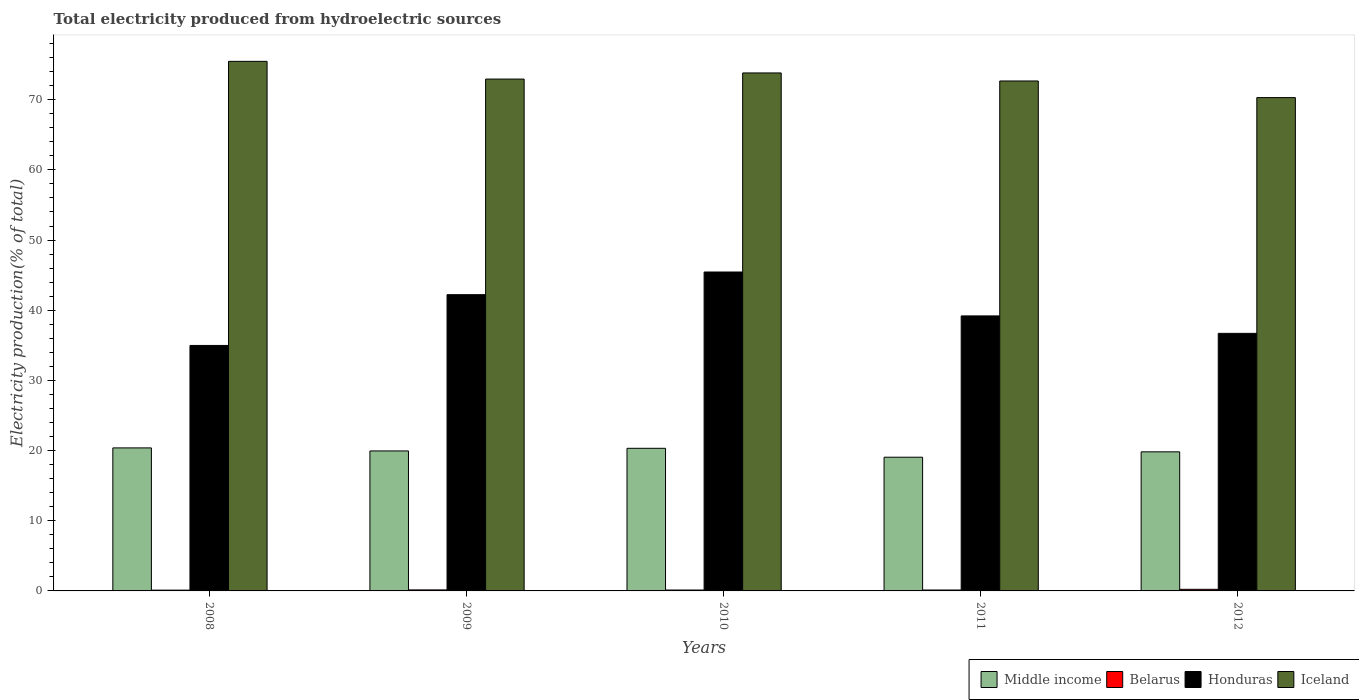How many different coloured bars are there?
Offer a terse response. 4. Are the number of bars per tick equal to the number of legend labels?
Your answer should be very brief. Yes. Are the number of bars on each tick of the X-axis equal?
Offer a terse response. Yes. How many bars are there on the 1st tick from the left?
Your answer should be very brief. 4. What is the label of the 2nd group of bars from the left?
Ensure brevity in your answer.  2009. In how many cases, is the number of bars for a given year not equal to the number of legend labels?
Keep it short and to the point. 0. What is the total electricity produced in Honduras in 2010?
Offer a very short reply. 45.45. Across all years, what is the maximum total electricity produced in Middle income?
Offer a very short reply. 20.38. Across all years, what is the minimum total electricity produced in Honduras?
Provide a succinct answer. 34.98. In which year was the total electricity produced in Middle income maximum?
Ensure brevity in your answer.  2008. What is the total total electricity produced in Iceland in the graph?
Your answer should be very brief. 365.19. What is the difference between the total electricity produced in Iceland in 2009 and that in 2011?
Your response must be concise. 0.27. What is the difference between the total electricity produced in Iceland in 2008 and the total electricity produced in Middle income in 2011?
Make the answer very short. 56.41. What is the average total electricity produced in Belarus per year?
Offer a very short reply. 0.15. In the year 2008, what is the difference between the total electricity produced in Honduras and total electricity produced in Middle income?
Provide a succinct answer. 14.6. What is the ratio of the total electricity produced in Iceland in 2008 to that in 2011?
Ensure brevity in your answer.  1.04. What is the difference between the highest and the second highest total electricity produced in Iceland?
Give a very brief answer. 1.65. What is the difference between the highest and the lowest total electricity produced in Iceland?
Provide a succinct answer. 5.17. Is the sum of the total electricity produced in Belarus in 2008 and 2011 greater than the maximum total electricity produced in Honduras across all years?
Provide a short and direct response. No. Is it the case that in every year, the sum of the total electricity produced in Middle income and total electricity produced in Iceland is greater than the sum of total electricity produced in Belarus and total electricity produced in Honduras?
Offer a very short reply. Yes. What does the 3rd bar from the left in 2009 represents?
Offer a terse response. Honduras. What does the 3rd bar from the right in 2008 represents?
Offer a terse response. Belarus. Is it the case that in every year, the sum of the total electricity produced in Iceland and total electricity produced in Honduras is greater than the total electricity produced in Belarus?
Offer a terse response. Yes. How many bars are there?
Provide a succinct answer. 20. How many years are there in the graph?
Offer a very short reply. 5. How are the legend labels stacked?
Your response must be concise. Horizontal. What is the title of the graph?
Your answer should be compact. Total electricity produced from hydroelectric sources. What is the Electricity production(% of total) in Middle income in 2008?
Give a very brief answer. 20.38. What is the Electricity production(% of total) in Belarus in 2008?
Your answer should be compact. 0.11. What is the Electricity production(% of total) of Honduras in 2008?
Your response must be concise. 34.98. What is the Electricity production(% of total) in Iceland in 2008?
Offer a very short reply. 75.47. What is the Electricity production(% of total) in Middle income in 2009?
Your answer should be compact. 19.95. What is the Electricity production(% of total) in Belarus in 2009?
Your answer should be very brief. 0.14. What is the Electricity production(% of total) of Honduras in 2009?
Ensure brevity in your answer.  42.22. What is the Electricity production(% of total) in Iceland in 2009?
Provide a succinct answer. 72.94. What is the Electricity production(% of total) of Middle income in 2010?
Keep it short and to the point. 20.32. What is the Electricity production(% of total) in Belarus in 2010?
Your response must be concise. 0.13. What is the Electricity production(% of total) of Honduras in 2010?
Keep it short and to the point. 45.45. What is the Electricity production(% of total) in Iceland in 2010?
Make the answer very short. 73.81. What is the Electricity production(% of total) in Middle income in 2011?
Make the answer very short. 19.05. What is the Electricity production(% of total) in Belarus in 2011?
Provide a succinct answer. 0.13. What is the Electricity production(% of total) in Honduras in 2011?
Your answer should be compact. 39.19. What is the Electricity production(% of total) in Iceland in 2011?
Your answer should be compact. 72.67. What is the Electricity production(% of total) of Middle income in 2012?
Your answer should be very brief. 19.82. What is the Electricity production(% of total) in Belarus in 2012?
Your answer should be compact. 0.23. What is the Electricity production(% of total) in Honduras in 2012?
Your answer should be very brief. 36.7. What is the Electricity production(% of total) in Iceland in 2012?
Your answer should be very brief. 70.3. Across all years, what is the maximum Electricity production(% of total) in Middle income?
Your answer should be compact. 20.38. Across all years, what is the maximum Electricity production(% of total) in Belarus?
Provide a succinct answer. 0.23. Across all years, what is the maximum Electricity production(% of total) in Honduras?
Your answer should be compact. 45.45. Across all years, what is the maximum Electricity production(% of total) in Iceland?
Offer a terse response. 75.47. Across all years, what is the minimum Electricity production(% of total) in Middle income?
Provide a short and direct response. 19.05. Across all years, what is the minimum Electricity production(% of total) of Belarus?
Offer a very short reply. 0.11. Across all years, what is the minimum Electricity production(% of total) of Honduras?
Offer a very short reply. 34.98. Across all years, what is the minimum Electricity production(% of total) in Iceland?
Ensure brevity in your answer.  70.3. What is the total Electricity production(% of total) of Middle income in the graph?
Offer a very short reply. 99.53. What is the total Electricity production(% of total) in Belarus in the graph?
Ensure brevity in your answer.  0.74. What is the total Electricity production(% of total) in Honduras in the graph?
Your answer should be compact. 198.54. What is the total Electricity production(% of total) of Iceland in the graph?
Offer a very short reply. 365.19. What is the difference between the Electricity production(% of total) in Middle income in 2008 and that in 2009?
Provide a short and direct response. 0.43. What is the difference between the Electricity production(% of total) in Belarus in 2008 and that in 2009?
Provide a succinct answer. -0.03. What is the difference between the Electricity production(% of total) in Honduras in 2008 and that in 2009?
Your answer should be very brief. -7.24. What is the difference between the Electricity production(% of total) in Iceland in 2008 and that in 2009?
Provide a short and direct response. 2.52. What is the difference between the Electricity production(% of total) in Middle income in 2008 and that in 2010?
Offer a terse response. 0.06. What is the difference between the Electricity production(% of total) of Belarus in 2008 and that in 2010?
Offer a terse response. -0.02. What is the difference between the Electricity production(% of total) in Honduras in 2008 and that in 2010?
Your answer should be compact. -10.47. What is the difference between the Electricity production(% of total) of Iceland in 2008 and that in 2010?
Keep it short and to the point. 1.65. What is the difference between the Electricity production(% of total) of Middle income in 2008 and that in 2011?
Offer a terse response. 1.33. What is the difference between the Electricity production(% of total) in Belarus in 2008 and that in 2011?
Keep it short and to the point. -0.02. What is the difference between the Electricity production(% of total) in Honduras in 2008 and that in 2011?
Ensure brevity in your answer.  -4.21. What is the difference between the Electricity production(% of total) in Iceland in 2008 and that in 2011?
Provide a short and direct response. 2.8. What is the difference between the Electricity production(% of total) of Middle income in 2008 and that in 2012?
Give a very brief answer. 0.56. What is the difference between the Electricity production(% of total) of Belarus in 2008 and that in 2012?
Offer a very short reply. -0.12. What is the difference between the Electricity production(% of total) of Honduras in 2008 and that in 2012?
Provide a succinct answer. -1.72. What is the difference between the Electricity production(% of total) in Iceland in 2008 and that in 2012?
Keep it short and to the point. 5.17. What is the difference between the Electricity production(% of total) of Middle income in 2009 and that in 2010?
Make the answer very short. -0.37. What is the difference between the Electricity production(% of total) of Belarus in 2009 and that in 2010?
Offer a terse response. 0.02. What is the difference between the Electricity production(% of total) in Honduras in 2009 and that in 2010?
Keep it short and to the point. -3.23. What is the difference between the Electricity production(% of total) of Iceland in 2009 and that in 2010?
Offer a terse response. -0.87. What is the difference between the Electricity production(% of total) of Middle income in 2009 and that in 2011?
Make the answer very short. 0.89. What is the difference between the Electricity production(% of total) in Belarus in 2009 and that in 2011?
Your answer should be very brief. 0.01. What is the difference between the Electricity production(% of total) of Honduras in 2009 and that in 2011?
Your response must be concise. 3.03. What is the difference between the Electricity production(% of total) of Iceland in 2009 and that in 2011?
Offer a very short reply. 0.27. What is the difference between the Electricity production(% of total) of Middle income in 2009 and that in 2012?
Provide a short and direct response. 0.13. What is the difference between the Electricity production(% of total) in Belarus in 2009 and that in 2012?
Keep it short and to the point. -0.08. What is the difference between the Electricity production(% of total) in Honduras in 2009 and that in 2012?
Give a very brief answer. 5.51. What is the difference between the Electricity production(% of total) in Iceland in 2009 and that in 2012?
Your answer should be very brief. 2.64. What is the difference between the Electricity production(% of total) in Middle income in 2010 and that in 2011?
Ensure brevity in your answer.  1.27. What is the difference between the Electricity production(% of total) of Belarus in 2010 and that in 2011?
Your response must be concise. -0. What is the difference between the Electricity production(% of total) of Honduras in 2010 and that in 2011?
Ensure brevity in your answer.  6.26. What is the difference between the Electricity production(% of total) of Iceland in 2010 and that in 2011?
Your answer should be compact. 1.15. What is the difference between the Electricity production(% of total) of Middle income in 2010 and that in 2012?
Provide a succinct answer. 0.5. What is the difference between the Electricity production(% of total) of Belarus in 2010 and that in 2012?
Offer a terse response. -0.1. What is the difference between the Electricity production(% of total) in Honduras in 2010 and that in 2012?
Provide a short and direct response. 8.74. What is the difference between the Electricity production(% of total) of Iceland in 2010 and that in 2012?
Provide a short and direct response. 3.51. What is the difference between the Electricity production(% of total) in Middle income in 2011 and that in 2012?
Keep it short and to the point. -0.77. What is the difference between the Electricity production(% of total) in Belarus in 2011 and that in 2012?
Ensure brevity in your answer.  -0.1. What is the difference between the Electricity production(% of total) of Honduras in 2011 and that in 2012?
Keep it short and to the point. 2.48. What is the difference between the Electricity production(% of total) of Iceland in 2011 and that in 2012?
Offer a terse response. 2.37. What is the difference between the Electricity production(% of total) in Middle income in 2008 and the Electricity production(% of total) in Belarus in 2009?
Your response must be concise. 20.24. What is the difference between the Electricity production(% of total) in Middle income in 2008 and the Electricity production(% of total) in Honduras in 2009?
Your response must be concise. -21.84. What is the difference between the Electricity production(% of total) in Middle income in 2008 and the Electricity production(% of total) in Iceland in 2009?
Provide a short and direct response. -52.56. What is the difference between the Electricity production(% of total) in Belarus in 2008 and the Electricity production(% of total) in Honduras in 2009?
Your response must be concise. -42.11. What is the difference between the Electricity production(% of total) in Belarus in 2008 and the Electricity production(% of total) in Iceland in 2009?
Offer a terse response. -72.83. What is the difference between the Electricity production(% of total) in Honduras in 2008 and the Electricity production(% of total) in Iceland in 2009?
Your answer should be compact. -37.96. What is the difference between the Electricity production(% of total) in Middle income in 2008 and the Electricity production(% of total) in Belarus in 2010?
Offer a terse response. 20.25. What is the difference between the Electricity production(% of total) of Middle income in 2008 and the Electricity production(% of total) of Honduras in 2010?
Offer a very short reply. -25.07. What is the difference between the Electricity production(% of total) of Middle income in 2008 and the Electricity production(% of total) of Iceland in 2010?
Ensure brevity in your answer.  -53.43. What is the difference between the Electricity production(% of total) in Belarus in 2008 and the Electricity production(% of total) in Honduras in 2010?
Make the answer very short. -45.34. What is the difference between the Electricity production(% of total) of Belarus in 2008 and the Electricity production(% of total) of Iceland in 2010?
Provide a succinct answer. -73.7. What is the difference between the Electricity production(% of total) in Honduras in 2008 and the Electricity production(% of total) in Iceland in 2010?
Give a very brief answer. -38.83. What is the difference between the Electricity production(% of total) of Middle income in 2008 and the Electricity production(% of total) of Belarus in 2011?
Ensure brevity in your answer.  20.25. What is the difference between the Electricity production(% of total) of Middle income in 2008 and the Electricity production(% of total) of Honduras in 2011?
Your response must be concise. -18.81. What is the difference between the Electricity production(% of total) of Middle income in 2008 and the Electricity production(% of total) of Iceland in 2011?
Ensure brevity in your answer.  -52.29. What is the difference between the Electricity production(% of total) of Belarus in 2008 and the Electricity production(% of total) of Honduras in 2011?
Make the answer very short. -39.08. What is the difference between the Electricity production(% of total) in Belarus in 2008 and the Electricity production(% of total) in Iceland in 2011?
Offer a very short reply. -72.56. What is the difference between the Electricity production(% of total) in Honduras in 2008 and the Electricity production(% of total) in Iceland in 2011?
Your answer should be compact. -37.69. What is the difference between the Electricity production(% of total) of Middle income in 2008 and the Electricity production(% of total) of Belarus in 2012?
Keep it short and to the point. 20.15. What is the difference between the Electricity production(% of total) in Middle income in 2008 and the Electricity production(% of total) in Honduras in 2012?
Keep it short and to the point. -16.32. What is the difference between the Electricity production(% of total) in Middle income in 2008 and the Electricity production(% of total) in Iceland in 2012?
Give a very brief answer. -49.92. What is the difference between the Electricity production(% of total) in Belarus in 2008 and the Electricity production(% of total) in Honduras in 2012?
Your answer should be compact. -36.59. What is the difference between the Electricity production(% of total) of Belarus in 2008 and the Electricity production(% of total) of Iceland in 2012?
Ensure brevity in your answer.  -70.19. What is the difference between the Electricity production(% of total) in Honduras in 2008 and the Electricity production(% of total) in Iceland in 2012?
Your answer should be compact. -35.32. What is the difference between the Electricity production(% of total) in Middle income in 2009 and the Electricity production(% of total) in Belarus in 2010?
Provide a short and direct response. 19.82. What is the difference between the Electricity production(% of total) of Middle income in 2009 and the Electricity production(% of total) of Honduras in 2010?
Provide a short and direct response. -25.5. What is the difference between the Electricity production(% of total) of Middle income in 2009 and the Electricity production(% of total) of Iceland in 2010?
Give a very brief answer. -53.87. What is the difference between the Electricity production(% of total) of Belarus in 2009 and the Electricity production(% of total) of Honduras in 2010?
Keep it short and to the point. -45.3. What is the difference between the Electricity production(% of total) of Belarus in 2009 and the Electricity production(% of total) of Iceland in 2010?
Keep it short and to the point. -73.67. What is the difference between the Electricity production(% of total) in Honduras in 2009 and the Electricity production(% of total) in Iceland in 2010?
Make the answer very short. -31.6. What is the difference between the Electricity production(% of total) in Middle income in 2009 and the Electricity production(% of total) in Belarus in 2011?
Your response must be concise. 19.82. What is the difference between the Electricity production(% of total) in Middle income in 2009 and the Electricity production(% of total) in Honduras in 2011?
Your answer should be compact. -19.24. What is the difference between the Electricity production(% of total) of Middle income in 2009 and the Electricity production(% of total) of Iceland in 2011?
Ensure brevity in your answer.  -52.72. What is the difference between the Electricity production(% of total) of Belarus in 2009 and the Electricity production(% of total) of Honduras in 2011?
Make the answer very short. -39.04. What is the difference between the Electricity production(% of total) of Belarus in 2009 and the Electricity production(% of total) of Iceland in 2011?
Provide a succinct answer. -72.52. What is the difference between the Electricity production(% of total) of Honduras in 2009 and the Electricity production(% of total) of Iceland in 2011?
Offer a very short reply. -30.45. What is the difference between the Electricity production(% of total) of Middle income in 2009 and the Electricity production(% of total) of Belarus in 2012?
Provide a short and direct response. 19.72. What is the difference between the Electricity production(% of total) of Middle income in 2009 and the Electricity production(% of total) of Honduras in 2012?
Keep it short and to the point. -16.76. What is the difference between the Electricity production(% of total) of Middle income in 2009 and the Electricity production(% of total) of Iceland in 2012?
Give a very brief answer. -50.35. What is the difference between the Electricity production(% of total) of Belarus in 2009 and the Electricity production(% of total) of Honduras in 2012?
Make the answer very short. -36.56. What is the difference between the Electricity production(% of total) of Belarus in 2009 and the Electricity production(% of total) of Iceland in 2012?
Your answer should be compact. -70.16. What is the difference between the Electricity production(% of total) in Honduras in 2009 and the Electricity production(% of total) in Iceland in 2012?
Your answer should be compact. -28.08. What is the difference between the Electricity production(% of total) of Middle income in 2010 and the Electricity production(% of total) of Belarus in 2011?
Make the answer very short. 20.19. What is the difference between the Electricity production(% of total) in Middle income in 2010 and the Electricity production(% of total) in Honduras in 2011?
Ensure brevity in your answer.  -18.87. What is the difference between the Electricity production(% of total) in Middle income in 2010 and the Electricity production(% of total) in Iceland in 2011?
Your response must be concise. -52.34. What is the difference between the Electricity production(% of total) of Belarus in 2010 and the Electricity production(% of total) of Honduras in 2011?
Make the answer very short. -39.06. What is the difference between the Electricity production(% of total) of Belarus in 2010 and the Electricity production(% of total) of Iceland in 2011?
Give a very brief answer. -72.54. What is the difference between the Electricity production(% of total) in Honduras in 2010 and the Electricity production(% of total) in Iceland in 2011?
Keep it short and to the point. -27.22. What is the difference between the Electricity production(% of total) of Middle income in 2010 and the Electricity production(% of total) of Belarus in 2012?
Provide a succinct answer. 20.1. What is the difference between the Electricity production(% of total) of Middle income in 2010 and the Electricity production(% of total) of Honduras in 2012?
Offer a very short reply. -16.38. What is the difference between the Electricity production(% of total) in Middle income in 2010 and the Electricity production(% of total) in Iceland in 2012?
Offer a very short reply. -49.98. What is the difference between the Electricity production(% of total) in Belarus in 2010 and the Electricity production(% of total) in Honduras in 2012?
Offer a terse response. -36.58. What is the difference between the Electricity production(% of total) of Belarus in 2010 and the Electricity production(% of total) of Iceland in 2012?
Your answer should be very brief. -70.17. What is the difference between the Electricity production(% of total) in Honduras in 2010 and the Electricity production(% of total) in Iceland in 2012?
Provide a succinct answer. -24.85. What is the difference between the Electricity production(% of total) in Middle income in 2011 and the Electricity production(% of total) in Belarus in 2012?
Offer a very short reply. 18.83. What is the difference between the Electricity production(% of total) in Middle income in 2011 and the Electricity production(% of total) in Honduras in 2012?
Your response must be concise. -17.65. What is the difference between the Electricity production(% of total) in Middle income in 2011 and the Electricity production(% of total) in Iceland in 2012?
Provide a short and direct response. -51.25. What is the difference between the Electricity production(% of total) in Belarus in 2011 and the Electricity production(% of total) in Honduras in 2012?
Provide a succinct answer. -36.57. What is the difference between the Electricity production(% of total) in Belarus in 2011 and the Electricity production(% of total) in Iceland in 2012?
Provide a short and direct response. -70.17. What is the difference between the Electricity production(% of total) in Honduras in 2011 and the Electricity production(% of total) in Iceland in 2012?
Make the answer very short. -31.11. What is the average Electricity production(% of total) of Middle income per year?
Give a very brief answer. 19.91. What is the average Electricity production(% of total) in Belarus per year?
Ensure brevity in your answer.  0.15. What is the average Electricity production(% of total) in Honduras per year?
Offer a very short reply. 39.71. What is the average Electricity production(% of total) in Iceland per year?
Keep it short and to the point. 73.04. In the year 2008, what is the difference between the Electricity production(% of total) in Middle income and Electricity production(% of total) in Belarus?
Make the answer very short. 20.27. In the year 2008, what is the difference between the Electricity production(% of total) of Middle income and Electricity production(% of total) of Honduras?
Your answer should be compact. -14.6. In the year 2008, what is the difference between the Electricity production(% of total) in Middle income and Electricity production(% of total) in Iceland?
Make the answer very short. -55.09. In the year 2008, what is the difference between the Electricity production(% of total) of Belarus and Electricity production(% of total) of Honduras?
Make the answer very short. -34.87. In the year 2008, what is the difference between the Electricity production(% of total) in Belarus and Electricity production(% of total) in Iceland?
Offer a very short reply. -75.35. In the year 2008, what is the difference between the Electricity production(% of total) in Honduras and Electricity production(% of total) in Iceland?
Keep it short and to the point. -40.48. In the year 2009, what is the difference between the Electricity production(% of total) of Middle income and Electricity production(% of total) of Belarus?
Offer a terse response. 19.8. In the year 2009, what is the difference between the Electricity production(% of total) of Middle income and Electricity production(% of total) of Honduras?
Provide a succinct answer. -22.27. In the year 2009, what is the difference between the Electricity production(% of total) in Middle income and Electricity production(% of total) in Iceland?
Your response must be concise. -52.99. In the year 2009, what is the difference between the Electricity production(% of total) of Belarus and Electricity production(% of total) of Honduras?
Make the answer very short. -42.07. In the year 2009, what is the difference between the Electricity production(% of total) in Belarus and Electricity production(% of total) in Iceland?
Your response must be concise. -72.8. In the year 2009, what is the difference between the Electricity production(% of total) of Honduras and Electricity production(% of total) of Iceland?
Your answer should be compact. -30.72. In the year 2010, what is the difference between the Electricity production(% of total) of Middle income and Electricity production(% of total) of Belarus?
Your response must be concise. 20.2. In the year 2010, what is the difference between the Electricity production(% of total) in Middle income and Electricity production(% of total) in Honduras?
Your response must be concise. -25.12. In the year 2010, what is the difference between the Electricity production(% of total) in Middle income and Electricity production(% of total) in Iceland?
Your answer should be very brief. -53.49. In the year 2010, what is the difference between the Electricity production(% of total) in Belarus and Electricity production(% of total) in Honduras?
Your answer should be very brief. -45.32. In the year 2010, what is the difference between the Electricity production(% of total) in Belarus and Electricity production(% of total) in Iceland?
Make the answer very short. -73.69. In the year 2010, what is the difference between the Electricity production(% of total) in Honduras and Electricity production(% of total) in Iceland?
Provide a succinct answer. -28.37. In the year 2011, what is the difference between the Electricity production(% of total) of Middle income and Electricity production(% of total) of Belarus?
Ensure brevity in your answer.  18.92. In the year 2011, what is the difference between the Electricity production(% of total) of Middle income and Electricity production(% of total) of Honduras?
Provide a succinct answer. -20.14. In the year 2011, what is the difference between the Electricity production(% of total) of Middle income and Electricity production(% of total) of Iceland?
Your answer should be very brief. -53.61. In the year 2011, what is the difference between the Electricity production(% of total) in Belarus and Electricity production(% of total) in Honduras?
Provide a short and direct response. -39.06. In the year 2011, what is the difference between the Electricity production(% of total) of Belarus and Electricity production(% of total) of Iceland?
Offer a terse response. -72.54. In the year 2011, what is the difference between the Electricity production(% of total) in Honduras and Electricity production(% of total) in Iceland?
Offer a terse response. -33.48. In the year 2012, what is the difference between the Electricity production(% of total) of Middle income and Electricity production(% of total) of Belarus?
Your answer should be compact. 19.59. In the year 2012, what is the difference between the Electricity production(% of total) in Middle income and Electricity production(% of total) in Honduras?
Provide a short and direct response. -16.89. In the year 2012, what is the difference between the Electricity production(% of total) of Middle income and Electricity production(% of total) of Iceland?
Provide a succinct answer. -50.48. In the year 2012, what is the difference between the Electricity production(% of total) of Belarus and Electricity production(% of total) of Honduras?
Make the answer very short. -36.48. In the year 2012, what is the difference between the Electricity production(% of total) in Belarus and Electricity production(% of total) in Iceland?
Offer a terse response. -70.07. In the year 2012, what is the difference between the Electricity production(% of total) in Honduras and Electricity production(% of total) in Iceland?
Give a very brief answer. -33.6. What is the ratio of the Electricity production(% of total) of Middle income in 2008 to that in 2009?
Offer a terse response. 1.02. What is the ratio of the Electricity production(% of total) in Belarus in 2008 to that in 2009?
Keep it short and to the point. 0.77. What is the ratio of the Electricity production(% of total) of Honduras in 2008 to that in 2009?
Give a very brief answer. 0.83. What is the ratio of the Electricity production(% of total) of Iceland in 2008 to that in 2009?
Keep it short and to the point. 1.03. What is the ratio of the Electricity production(% of total) in Middle income in 2008 to that in 2010?
Your response must be concise. 1. What is the ratio of the Electricity production(% of total) of Belarus in 2008 to that in 2010?
Offer a very short reply. 0.86. What is the ratio of the Electricity production(% of total) in Honduras in 2008 to that in 2010?
Provide a succinct answer. 0.77. What is the ratio of the Electricity production(% of total) in Iceland in 2008 to that in 2010?
Give a very brief answer. 1.02. What is the ratio of the Electricity production(% of total) in Middle income in 2008 to that in 2011?
Offer a very short reply. 1.07. What is the ratio of the Electricity production(% of total) of Belarus in 2008 to that in 2011?
Your answer should be compact. 0.85. What is the ratio of the Electricity production(% of total) in Honduras in 2008 to that in 2011?
Keep it short and to the point. 0.89. What is the ratio of the Electricity production(% of total) in Middle income in 2008 to that in 2012?
Ensure brevity in your answer.  1.03. What is the ratio of the Electricity production(% of total) of Belarus in 2008 to that in 2012?
Ensure brevity in your answer.  0.49. What is the ratio of the Electricity production(% of total) in Honduras in 2008 to that in 2012?
Offer a terse response. 0.95. What is the ratio of the Electricity production(% of total) in Iceland in 2008 to that in 2012?
Offer a very short reply. 1.07. What is the ratio of the Electricity production(% of total) of Middle income in 2009 to that in 2010?
Give a very brief answer. 0.98. What is the ratio of the Electricity production(% of total) of Belarus in 2009 to that in 2010?
Provide a succinct answer. 1.12. What is the ratio of the Electricity production(% of total) of Honduras in 2009 to that in 2010?
Offer a terse response. 0.93. What is the ratio of the Electricity production(% of total) of Middle income in 2009 to that in 2011?
Your response must be concise. 1.05. What is the ratio of the Electricity production(% of total) in Belarus in 2009 to that in 2011?
Offer a very short reply. 1.11. What is the ratio of the Electricity production(% of total) of Honduras in 2009 to that in 2011?
Keep it short and to the point. 1.08. What is the ratio of the Electricity production(% of total) in Iceland in 2009 to that in 2011?
Your answer should be very brief. 1. What is the ratio of the Electricity production(% of total) of Belarus in 2009 to that in 2012?
Make the answer very short. 0.64. What is the ratio of the Electricity production(% of total) of Honduras in 2009 to that in 2012?
Your answer should be compact. 1.15. What is the ratio of the Electricity production(% of total) in Iceland in 2009 to that in 2012?
Keep it short and to the point. 1.04. What is the ratio of the Electricity production(% of total) in Middle income in 2010 to that in 2011?
Provide a succinct answer. 1.07. What is the ratio of the Electricity production(% of total) of Belarus in 2010 to that in 2011?
Offer a very short reply. 0.99. What is the ratio of the Electricity production(% of total) in Honduras in 2010 to that in 2011?
Provide a succinct answer. 1.16. What is the ratio of the Electricity production(% of total) in Iceland in 2010 to that in 2011?
Make the answer very short. 1.02. What is the ratio of the Electricity production(% of total) in Middle income in 2010 to that in 2012?
Give a very brief answer. 1.03. What is the ratio of the Electricity production(% of total) of Belarus in 2010 to that in 2012?
Offer a terse response. 0.57. What is the ratio of the Electricity production(% of total) of Honduras in 2010 to that in 2012?
Your answer should be compact. 1.24. What is the ratio of the Electricity production(% of total) of Iceland in 2010 to that in 2012?
Keep it short and to the point. 1.05. What is the ratio of the Electricity production(% of total) of Middle income in 2011 to that in 2012?
Make the answer very short. 0.96. What is the ratio of the Electricity production(% of total) of Belarus in 2011 to that in 2012?
Offer a terse response. 0.57. What is the ratio of the Electricity production(% of total) in Honduras in 2011 to that in 2012?
Your response must be concise. 1.07. What is the ratio of the Electricity production(% of total) in Iceland in 2011 to that in 2012?
Provide a succinct answer. 1.03. What is the difference between the highest and the second highest Electricity production(% of total) in Middle income?
Give a very brief answer. 0.06. What is the difference between the highest and the second highest Electricity production(% of total) of Belarus?
Make the answer very short. 0.08. What is the difference between the highest and the second highest Electricity production(% of total) of Honduras?
Make the answer very short. 3.23. What is the difference between the highest and the second highest Electricity production(% of total) of Iceland?
Ensure brevity in your answer.  1.65. What is the difference between the highest and the lowest Electricity production(% of total) in Middle income?
Give a very brief answer. 1.33. What is the difference between the highest and the lowest Electricity production(% of total) in Belarus?
Make the answer very short. 0.12. What is the difference between the highest and the lowest Electricity production(% of total) in Honduras?
Your response must be concise. 10.47. What is the difference between the highest and the lowest Electricity production(% of total) in Iceland?
Provide a short and direct response. 5.17. 